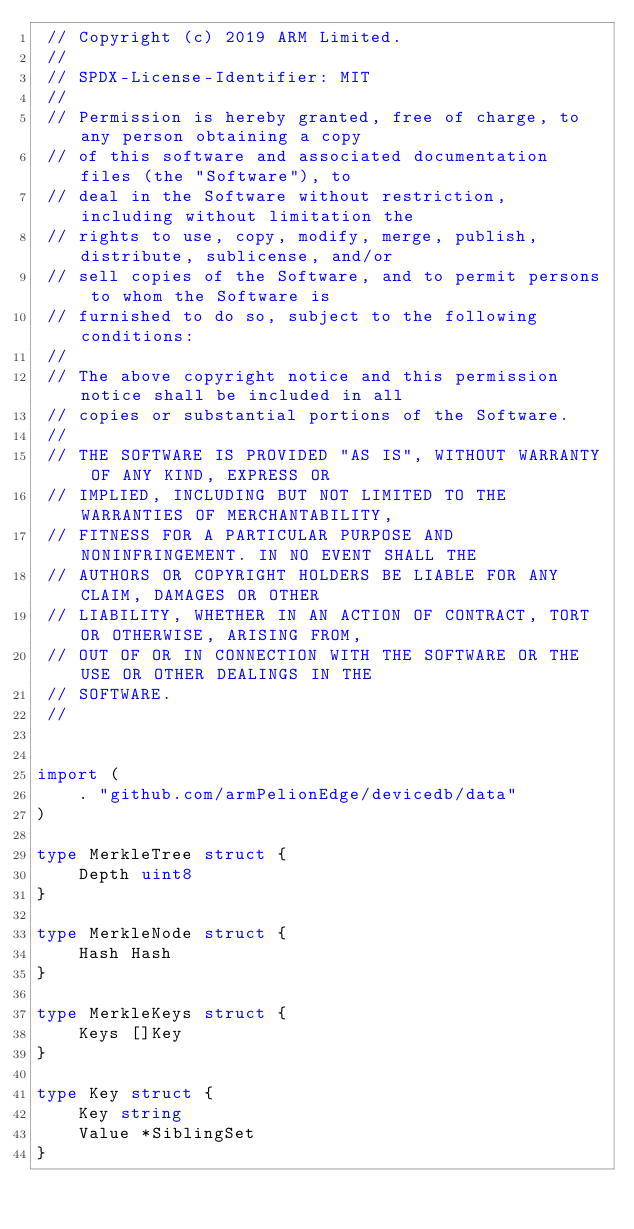<code> <loc_0><loc_0><loc_500><loc_500><_Go_> // Copyright (c) 2019 ARM Limited.
 //
 // SPDX-License-Identifier: MIT
 //
 // Permission is hereby granted, free of charge, to any person obtaining a copy
 // of this software and associated documentation files (the "Software"), to
 // deal in the Software without restriction, including without limitation the
 // rights to use, copy, modify, merge, publish, distribute, sublicense, and/or
 // sell copies of the Software, and to permit persons to whom the Software is
 // furnished to do so, subject to the following conditions:
 //
 // The above copyright notice and this permission notice shall be included in all
 // copies or substantial portions of the Software.
 //
 // THE SOFTWARE IS PROVIDED "AS IS", WITHOUT WARRANTY OF ANY KIND, EXPRESS OR
 // IMPLIED, INCLUDING BUT NOT LIMITED TO THE WARRANTIES OF MERCHANTABILITY,
 // FITNESS FOR A PARTICULAR PURPOSE AND NONINFRINGEMENT. IN NO EVENT SHALL THE
 // AUTHORS OR COPYRIGHT HOLDERS BE LIABLE FOR ANY CLAIM, DAMAGES OR OTHER
 // LIABILITY, WHETHER IN AN ACTION OF CONTRACT, TORT OR OTHERWISE, ARISING FROM,
 // OUT OF OR IN CONNECTION WITH THE SOFTWARE OR THE USE OR OTHER DEALINGS IN THE
 // SOFTWARE.
 //


import (
    . "github.com/armPelionEdge/devicedb/data"
)

type MerkleTree struct {
    Depth uint8
}

type MerkleNode struct {
    Hash Hash
}

type MerkleKeys struct {
    Keys []Key
}

type Key struct {
    Key string
    Value *SiblingSet
}</code> 